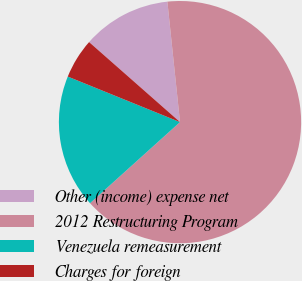Convert chart. <chart><loc_0><loc_0><loc_500><loc_500><pie_chart><fcel>Other (income) expense net<fcel>2012 Restructuring Program<fcel>Venezuela remeasurement<fcel>Charges for foreign<nl><fcel>11.85%<fcel>64.98%<fcel>17.81%<fcel>5.35%<nl></chart> 